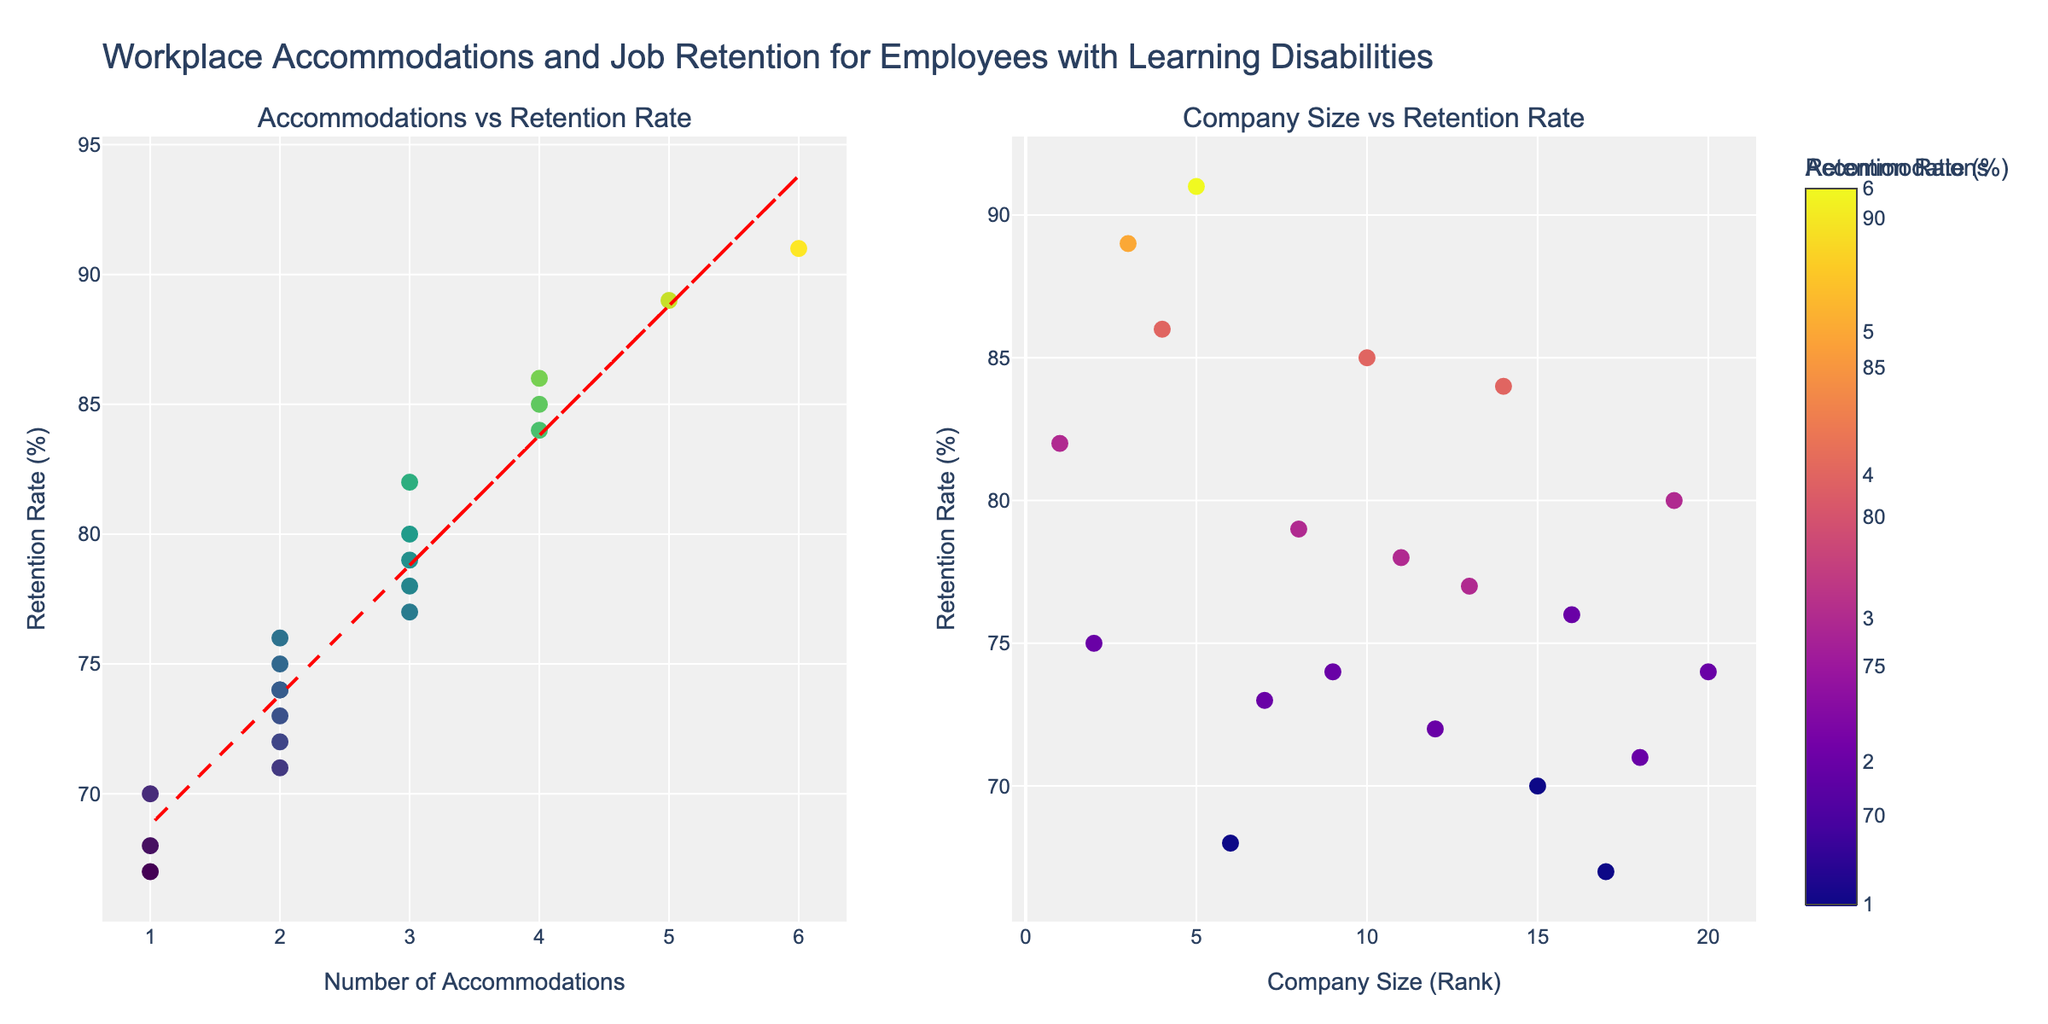What's the title of the figure? The title is prominently displayed at the top of the figure. It reads "Publication Trends in Literary Genres (1920-2020)".
Answer: Publication Trends in Literary Genres (1920-2020) What are the axes labels for the subplots? Each subplot has its x-axis labeled "Year" and its y-axis labeled "Number of Publications".
Answer: Year (x-axis), Number of Publications (y-axis) How many genres are displayed in the figure? There are five genres displayed in the figure as subplots: Novel, Poetry, Drama, Short Story, and Literary Criticism.
Answer: Five Which genre had the highest number of publications in 2000? By looking at the subplot for the year 2000, we see that the genre with the highest number of publications is "Novel" with 85 publications.
Answer: Novel Which genre experienced the largest decline in publications from 1920 to 2020? By comparing the subplots, "Drama" shows a decline from 20 publications in 1920 to 8 publications in 2020, a decrease of 12.
Answer: Drama What’s the difference in the number of publications of Short Story between 1940 and 2000? In 1940, "Short Story" had 40 publications. In 2000, it had 55 publications. The difference is 55 - 40 = 15.
Answer: 15 Which genres show a consistent increase in publications over the century? The subplots for "Novel", "Short Story", and "Literary Criticism" all show a consistent increase from 1920 to 2020.
Answer: Novel, Short Story, Literary Criticism Between which years did Poetry see the most significant drop in publications? Poetry dropped from 30 publications in 1920 to 25 in 1940, and then from 25 in 1940 to 22 in 1960. The most significant drop is from 1920 to 1940, decreasing by 5.
Answer: 1920 to 1940 How does the trend of Literary Criticism differ from the trend of Novel? "Literary Criticism" starts with the lowest number in 1920, then steadily increases, whereas "Novel" starts higher and consistently remains the genre with the most publications.
Answer: Literary Criticism increases steadily; Novel starts and remains highest 